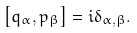<formula> <loc_0><loc_0><loc_500><loc_500>\left [ q _ { \alpha } , p _ { \beta } \right ] = i \delta _ { \alpha , \beta } .</formula> 